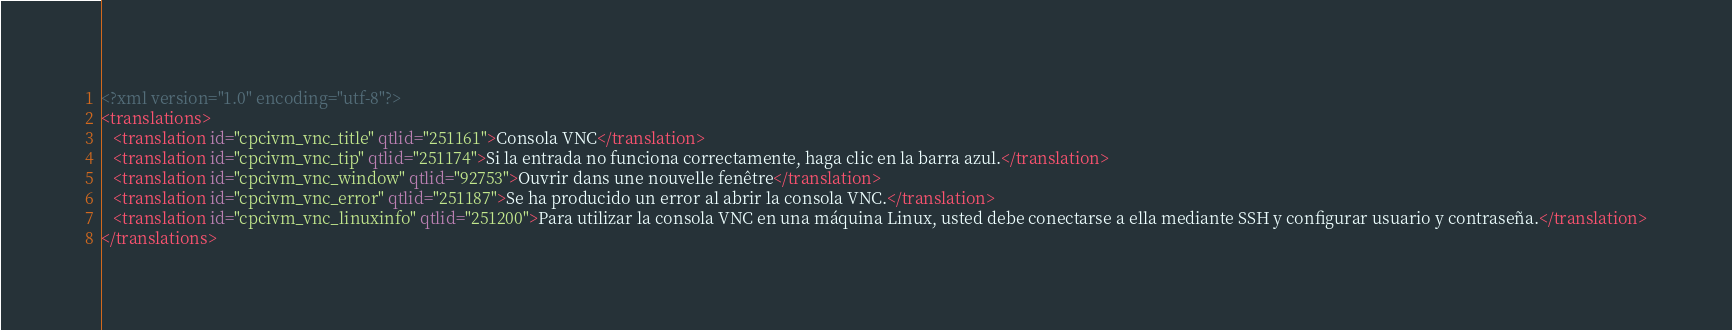Convert code to text. <code><loc_0><loc_0><loc_500><loc_500><_XML_><?xml version="1.0" encoding="utf-8"?>
<translations>
   <translation id="cpcivm_vnc_title" qtlid="251161">Consola VNC</translation>
   <translation id="cpcivm_vnc_tip" qtlid="251174">Si la entrada no funciona correctamente, haga clic en la barra azul.</translation>
   <translation id="cpcivm_vnc_window" qtlid="92753">Ouvrir dans une nouvelle fenêtre</translation>
   <translation id="cpcivm_vnc_error" qtlid="251187">Se ha producido un error al abrir la consola VNC.</translation>
   <translation id="cpcivm_vnc_linuxinfo" qtlid="251200">Para utilizar la consola VNC en una máquina Linux, usted debe conectarse a ella mediante SSH y configurar usuario y contraseña.</translation>
</translations>
</code> 